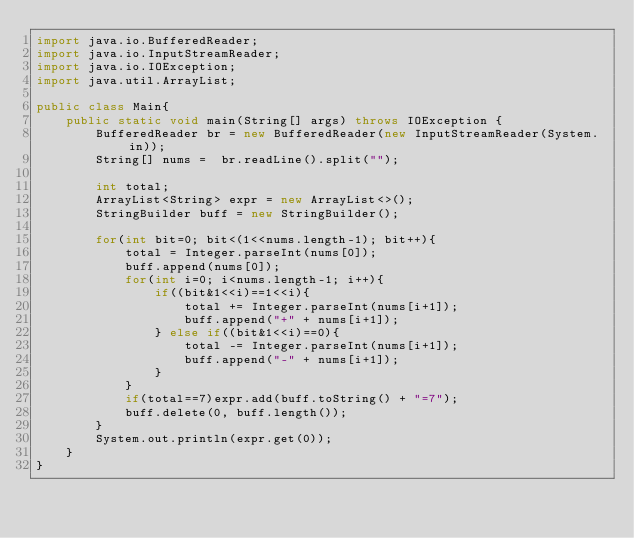Convert code to text. <code><loc_0><loc_0><loc_500><loc_500><_Java_>import java.io.BufferedReader;
import java.io.InputStreamReader;
import java.io.IOException;
import java.util.ArrayList;

public class Main{
    public static void main(String[] args) throws IOException {
        BufferedReader br = new BufferedReader(new InputStreamReader(System.in));
        String[] nums =  br.readLine().split("");
        
        int total;
        ArrayList<String> expr = new ArrayList<>();
        StringBuilder buff = new StringBuilder();
        
        for(int bit=0; bit<(1<<nums.length-1); bit++){
            total = Integer.parseInt(nums[0]);
            buff.append(nums[0]);
            for(int i=0; i<nums.length-1; i++){
                if((bit&1<<i)==1<<i){
                    total += Integer.parseInt(nums[i+1]);
                    buff.append("+" + nums[i+1]);
                } else if((bit&1<<i)==0){
                    total -= Integer.parseInt(nums[i+1]);
                    buff.append("-" + nums[i+1]);
                }
            }
            if(total==7)expr.add(buff.toString() + "=7");
            buff.delete(0, buff.length());
        }
        System.out.println(expr.get(0));
    }
}</code> 